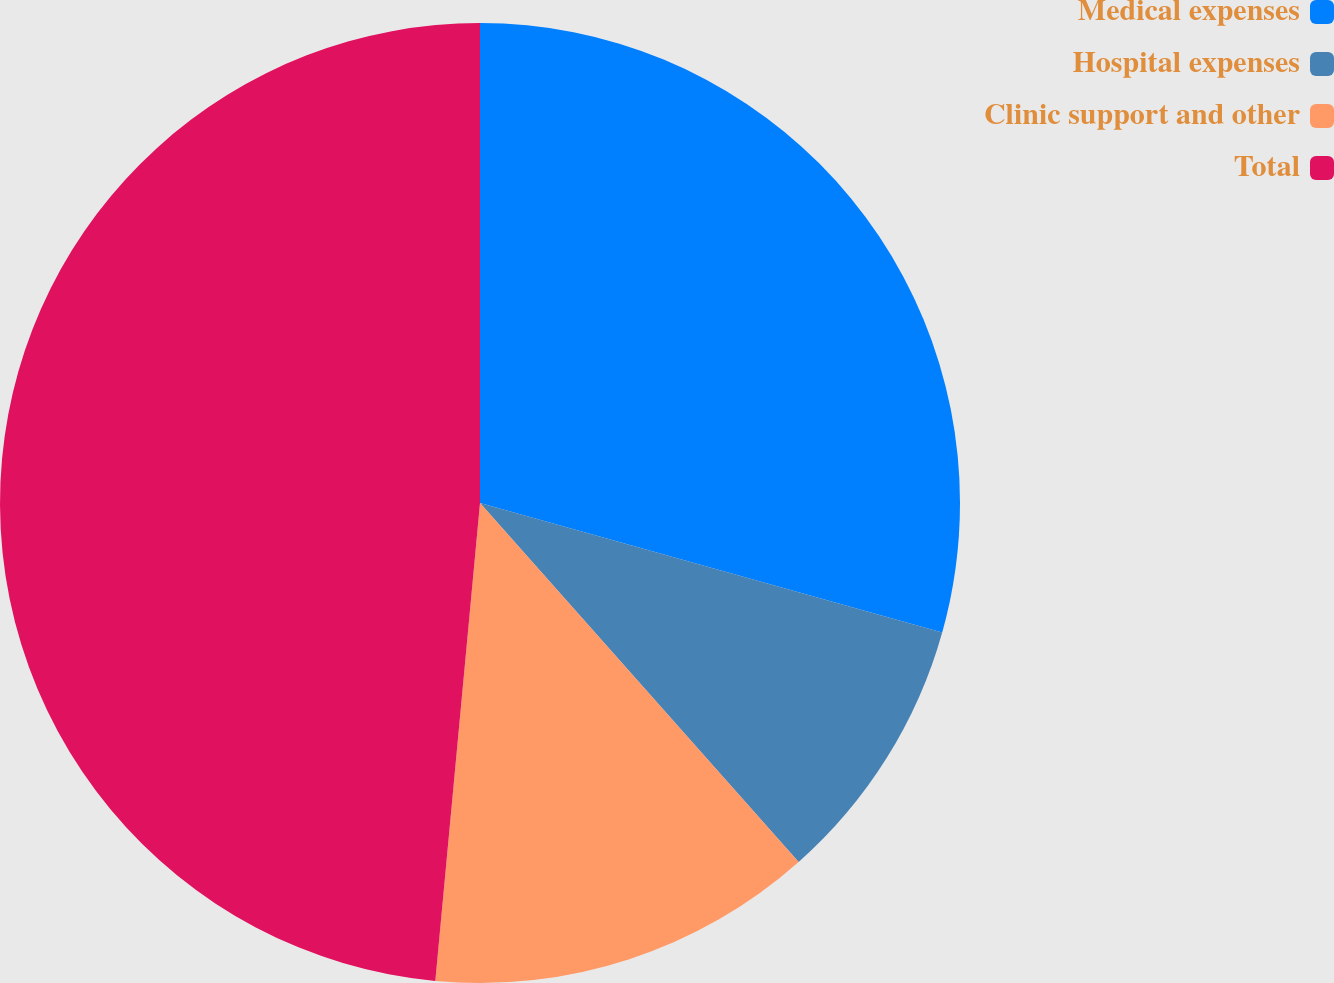Convert chart to OTSL. <chart><loc_0><loc_0><loc_500><loc_500><pie_chart><fcel>Medical expenses<fcel>Hospital expenses<fcel>Clinic support and other<fcel>Total<nl><fcel>29.35%<fcel>9.1%<fcel>13.04%<fcel>48.52%<nl></chart> 